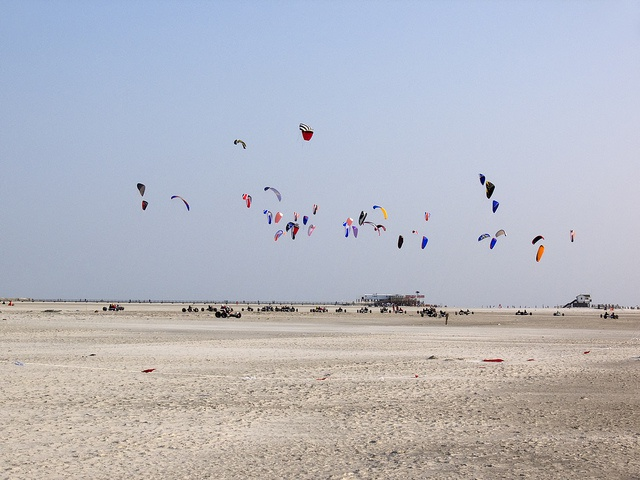Describe the objects in this image and their specific colors. I can see kite in darkgray and lightgray tones, kite in darkgray, maroon, lightgray, and black tones, kite in darkgray, black, gray, and maroon tones, kite in darkgray, black, gray, tan, and olive tones, and kite in darkgray, gray, and lightgray tones in this image. 